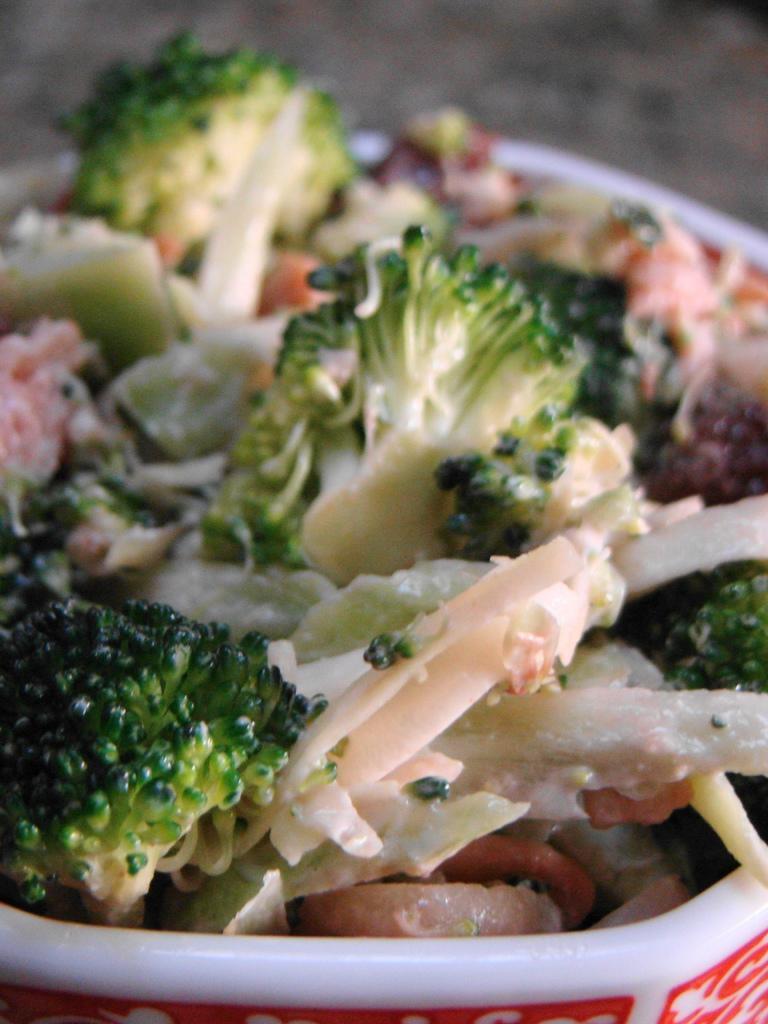Could you give a brief overview of what you see in this image? In this picture I can see a bucket, in which there is broccoli and other which is of white and brown color. I see that it is blurred in the background. 